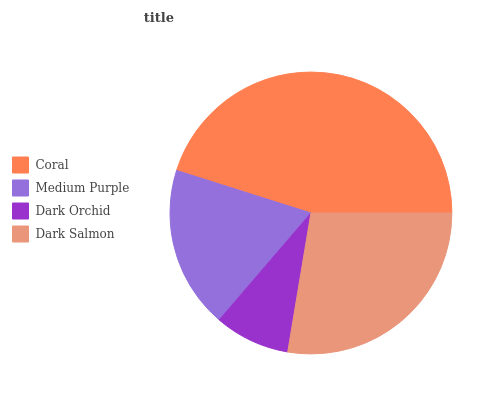Is Dark Orchid the minimum?
Answer yes or no. Yes. Is Coral the maximum?
Answer yes or no. Yes. Is Medium Purple the minimum?
Answer yes or no. No. Is Medium Purple the maximum?
Answer yes or no. No. Is Coral greater than Medium Purple?
Answer yes or no. Yes. Is Medium Purple less than Coral?
Answer yes or no. Yes. Is Medium Purple greater than Coral?
Answer yes or no. No. Is Coral less than Medium Purple?
Answer yes or no. No. Is Dark Salmon the high median?
Answer yes or no. Yes. Is Medium Purple the low median?
Answer yes or no. Yes. Is Medium Purple the high median?
Answer yes or no. No. Is Dark Salmon the low median?
Answer yes or no. No. 